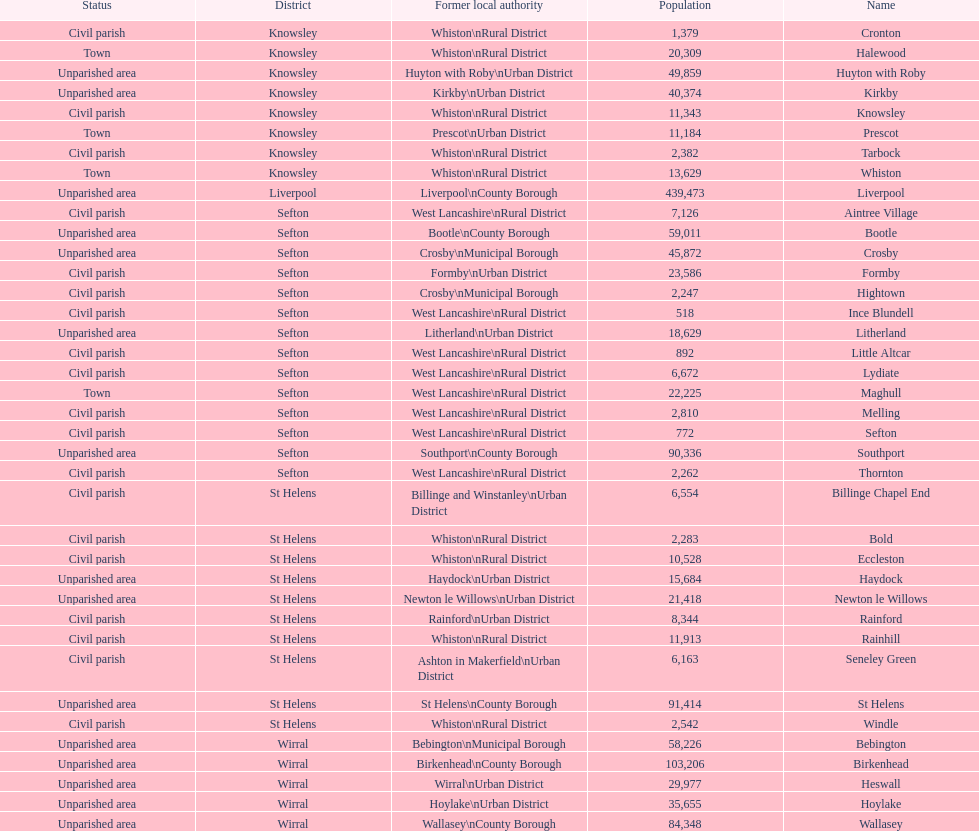Which area has the least number of residents? Ince Blundell. 